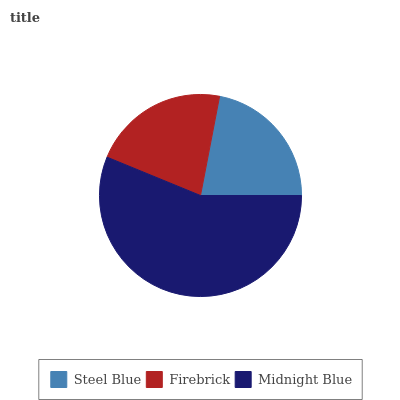Is Firebrick the minimum?
Answer yes or no. Yes. Is Midnight Blue the maximum?
Answer yes or no. Yes. Is Midnight Blue the minimum?
Answer yes or no. No. Is Firebrick the maximum?
Answer yes or no. No. Is Midnight Blue greater than Firebrick?
Answer yes or no. Yes. Is Firebrick less than Midnight Blue?
Answer yes or no. Yes. Is Firebrick greater than Midnight Blue?
Answer yes or no. No. Is Midnight Blue less than Firebrick?
Answer yes or no. No. Is Steel Blue the high median?
Answer yes or no. Yes. Is Steel Blue the low median?
Answer yes or no. Yes. Is Firebrick the high median?
Answer yes or no. No. Is Midnight Blue the low median?
Answer yes or no. No. 